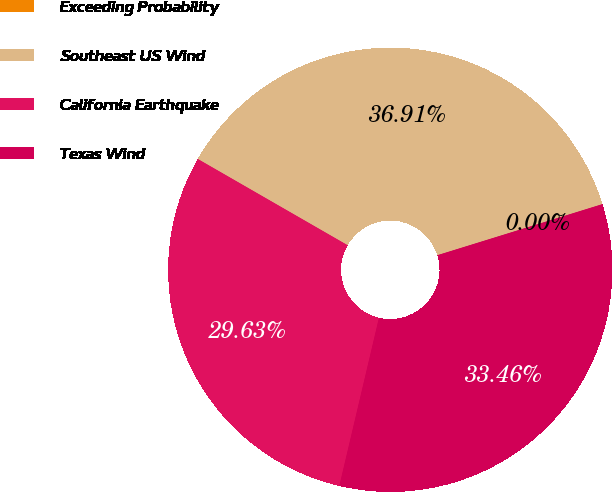Convert chart. <chart><loc_0><loc_0><loc_500><loc_500><pie_chart><fcel>Exceeding Probability<fcel>Southeast US Wind<fcel>California Earthquake<fcel>Texas Wind<nl><fcel>0.0%<fcel>36.91%<fcel>29.63%<fcel>33.46%<nl></chart> 